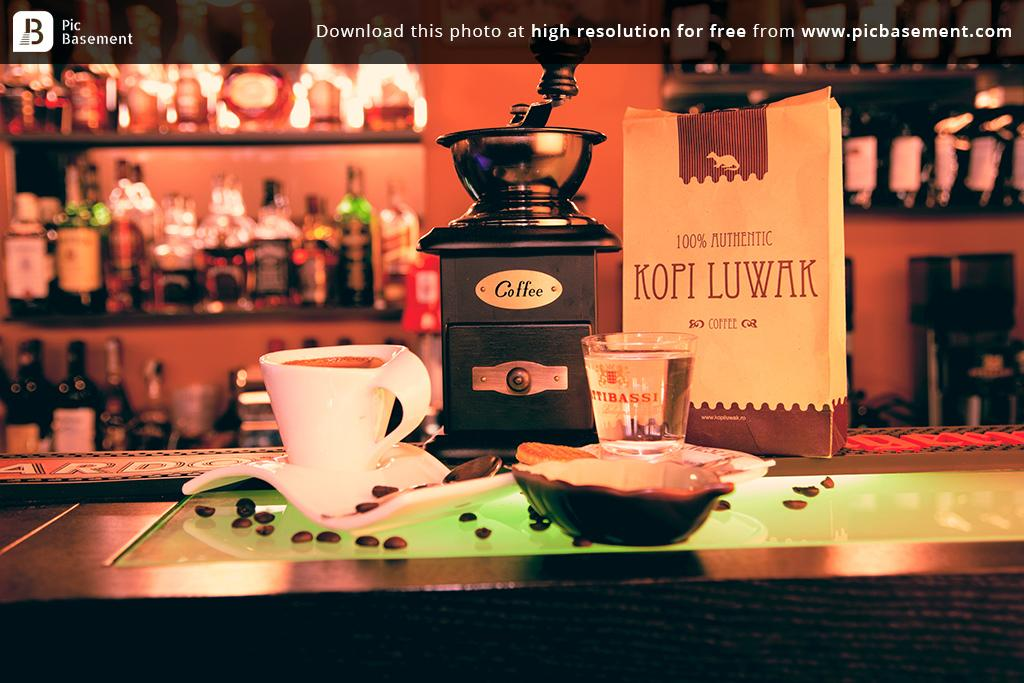<image>
Summarize the visual content of the image. A photo of some coffee which says that you can 'download for free.' 